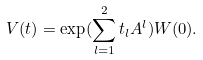Convert formula to latex. <formula><loc_0><loc_0><loc_500><loc_500>V ( t ) = \exp ( \sum _ { l = 1 } ^ { 2 } t _ { l } A ^ { l } ) W ( 0 ) .</formula> 